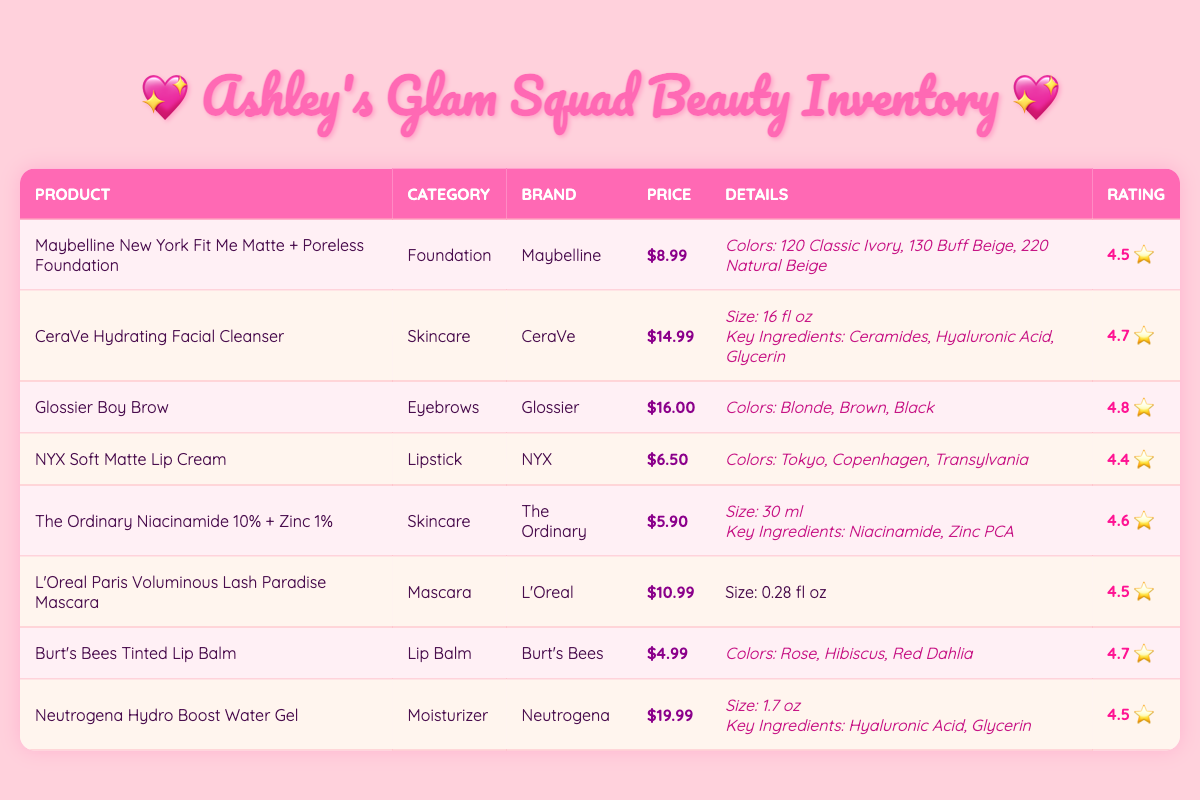What is the price of the Burts Bees Tinted Lip Balm? The table lists the price of Burt's Bees Tinted Lip Balm, which is indicated in the Price column as $4.99.
Answer: $4.99 Which product has the highest rating? By reviewing the Rating column, Glossier Boy Brow is listed with the highest rating of 4.8 stars.
Answer: Glossier Boy Brow Are there any skincare products in this inventory? A scan of the table reveals two entries under the category 'Skincare': CeraVe Hydrating Facial Cleanser and The Ordinary Niacinamide 10% + Zinc 1%. So, yes, there are skincare products.
Answer: Yes What is the average price of all the lip products? The two lip products are NYX Soft Matte Lip Cream at $6.50 and Burt's Bees Tinted Lip Balm at $4.99. Their total price is $6.50 + $4.99 = $11.49, and dividing this by 2 gives $5.74, the average price of lip products.
Answer: $5.74 Does the CeraVe Hydrating Facial Cleanser have Hyaluronic Acid as a key ingredient? Yes, it lists Hyaluronic Acid in the Key Ingredients section. Therefore, the statement is true.
Answer: Yes What is the total number of available colors for the Maybelline foundation? The available colors for the Maybelline foundation are 120 Classic Ivory, 130 Buff Beige, and 220 Natural Beige. That totals to 3 options.
Answer: 3 What category does the L'Oreal Paris Voluminous Lash Paradise Mascara belong to? The L'Oreal mascara is classified under the 'Mascara' category as per the table.
Answer: Mascara Which product has the lowest price? By checking each product's price, Burt's Bees Tinted Lip Balm at $4.99 is the lowest priced product.
Answer: Burt's Bees Tinted Lip Balm 